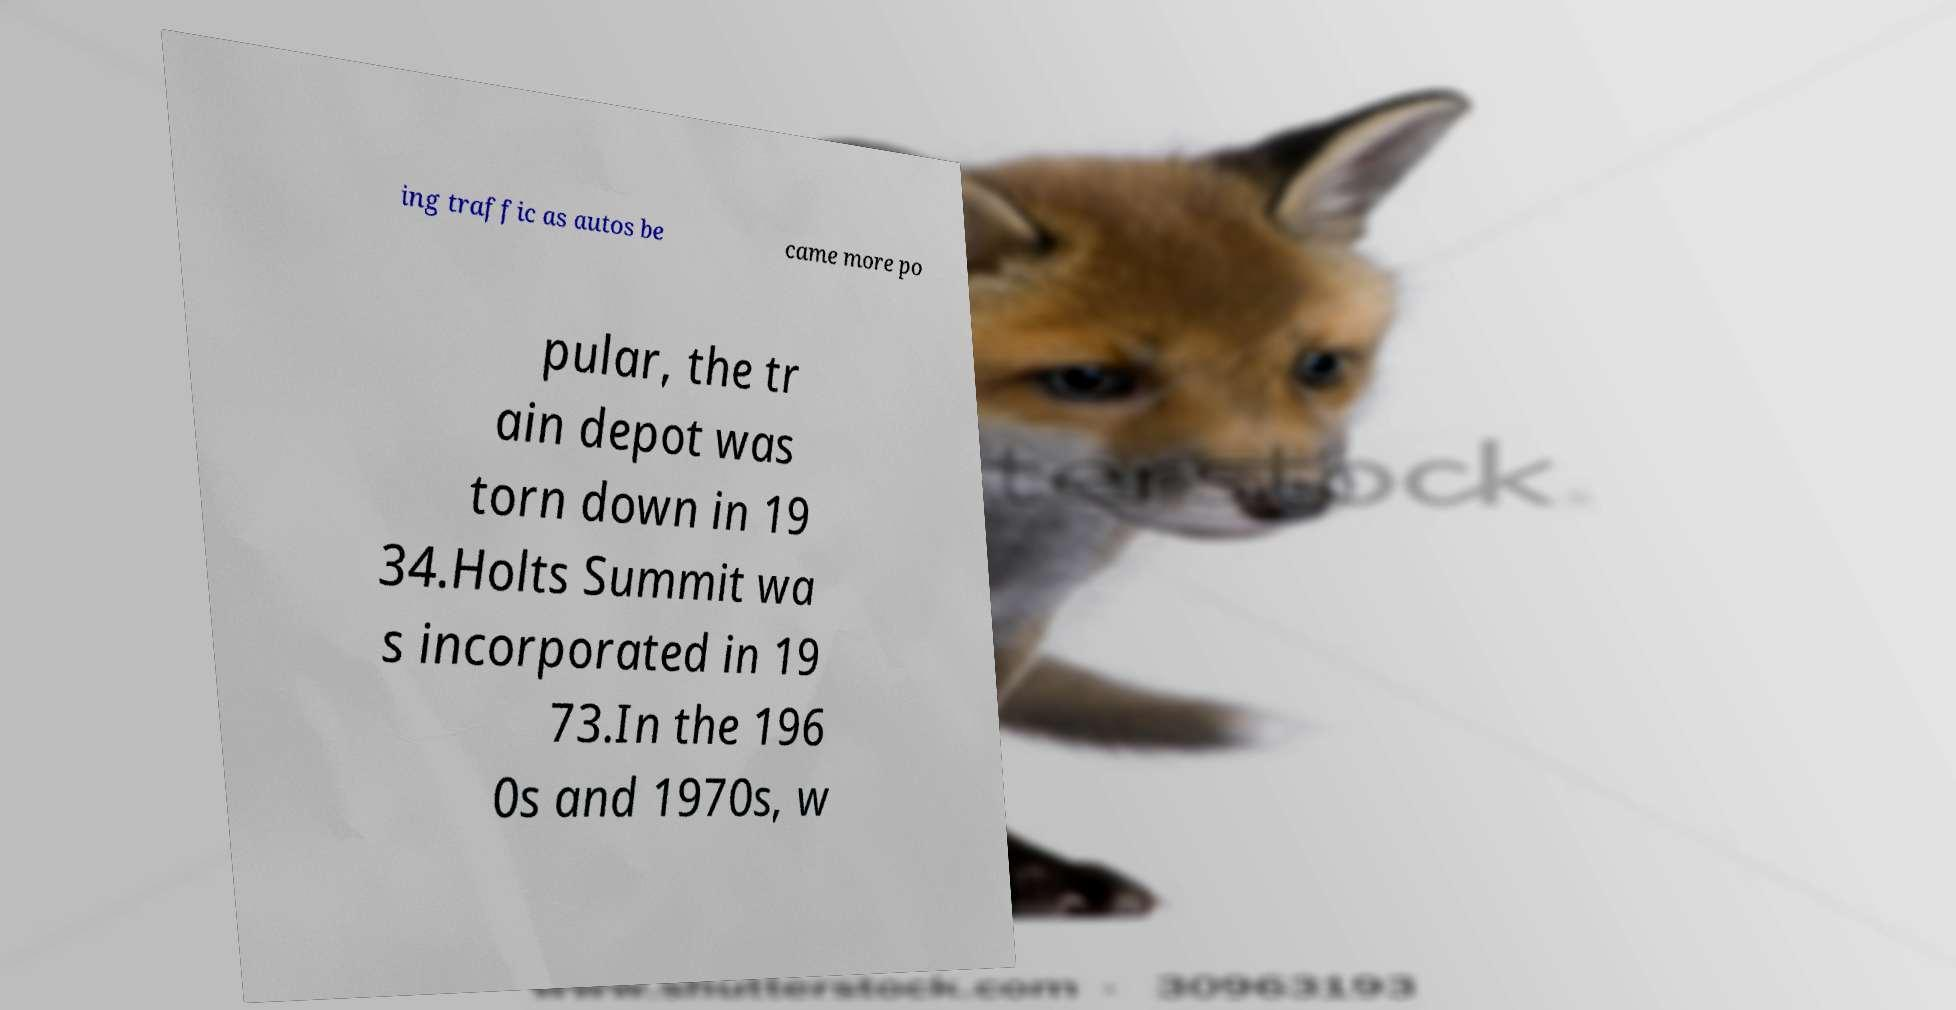I need the written content from this picture converted into text. Can you do that? ing traffic as autos be came more po pular, the tr ain depot was torn down in 19 34.Holts Summit wa s incorporated in 19 73.In the 196 0s and 1970s, w 